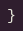Convert code to text. <code><loc_0><loc_0><loc_500><loc_500><_C_>}
</code> 